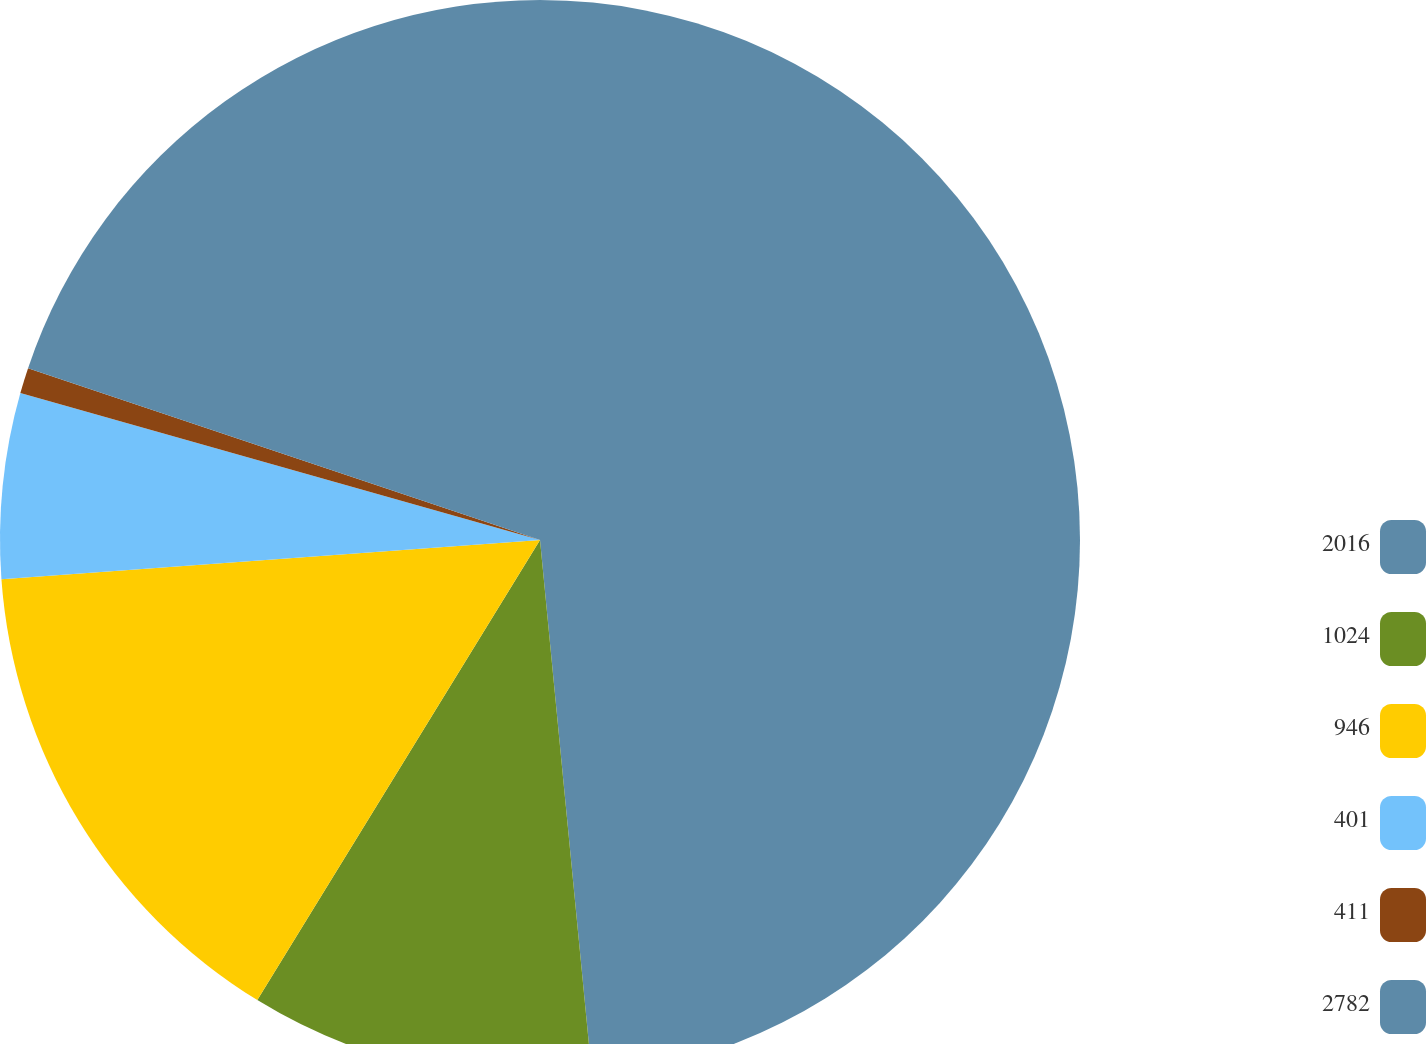Convert chart. <chart><loc_0><loc_0><loc_500><loc_500><pie_chart><fcel>2016<fcel>1024<fcel>946<fcel>401<fcel>411<fcel>2782<nl><fcel>48.47%<fcel>10.31%<fcel>15.08%<fcel>5.54%<fcel>0.77%<fcel>19.85%<nl></chart> 